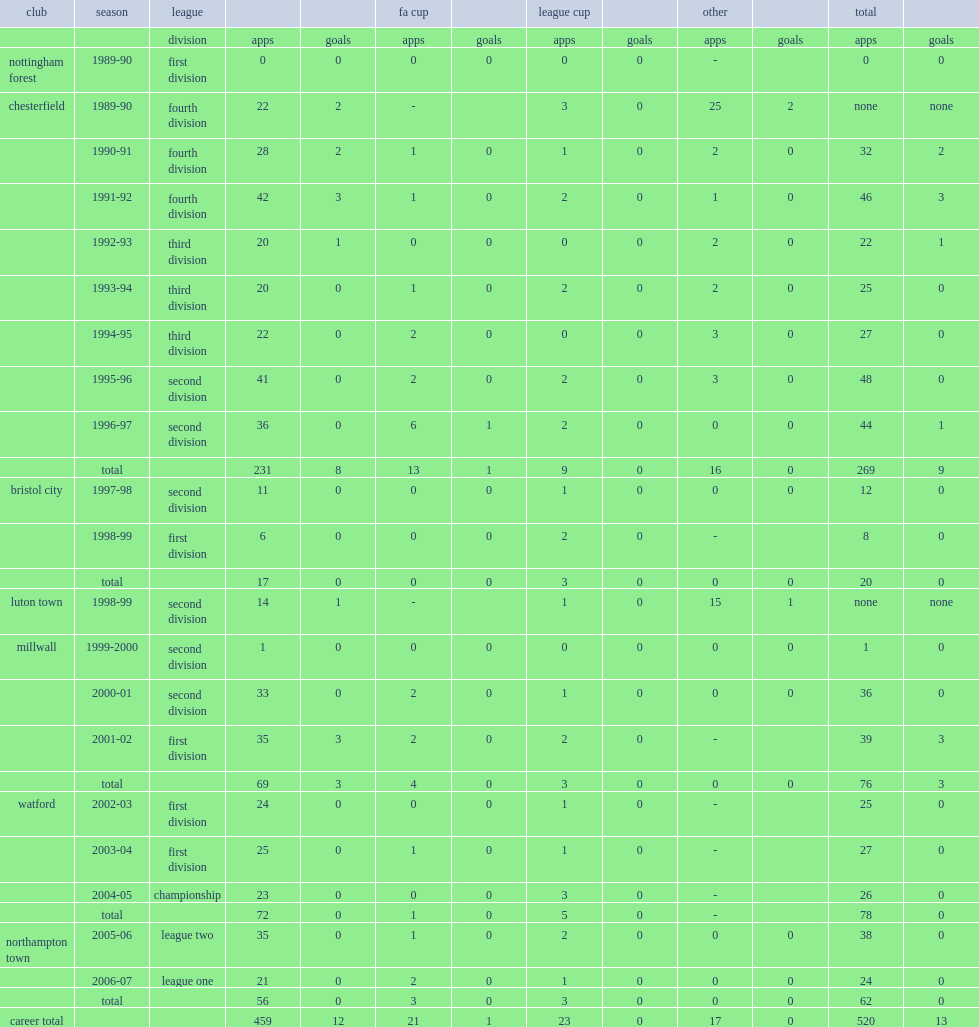In 2005-06, which club did sean dyche appear in league two? Northampton town. 